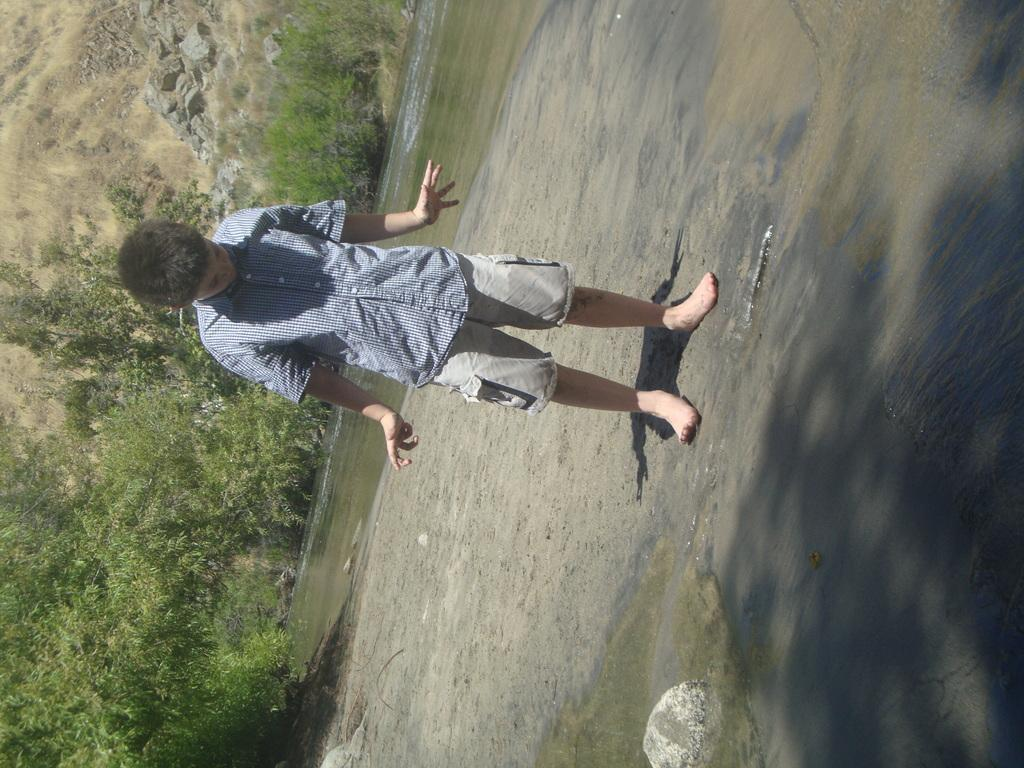What is the boy doing in the image? The boy is standing on the land in the image. What can be seen in the background of the image? There is water visible in the image. What type of natural features are present in the image? Rocks, a hill, plants, and trees are present in the image. What is the price of the shock that the boy experiences in the image? There is no shock or price mentioned in the image; the boy is simply standing on the land. 